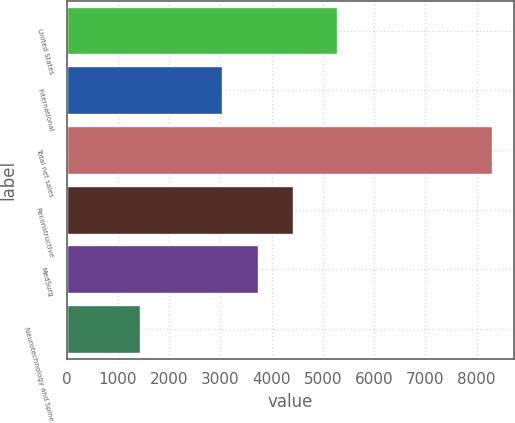Convert chart to OTSL. <chart><loc_0><loc_0><loc_500><loc_500><bar_chart><fcel>United States<fcel>International<fcel>Total net sales<fcel>Reconstructive<fcel>MedSurg<fcel>Neurotechnology and Spine<nl><fcel>5269<fcel>3038<fcel>8307<fcel>4412<fcel>3725<fcel>1437<nl></chart> 